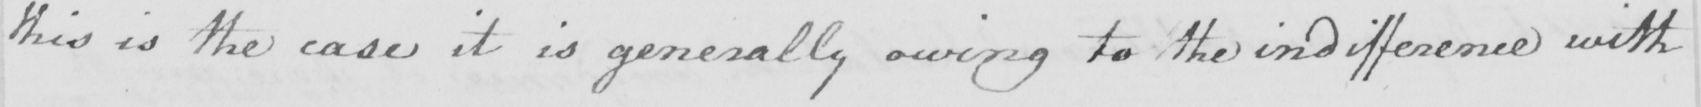Transcribe the text shown in this historical manuscript line. this is the case it is generally owing to the indifference with 